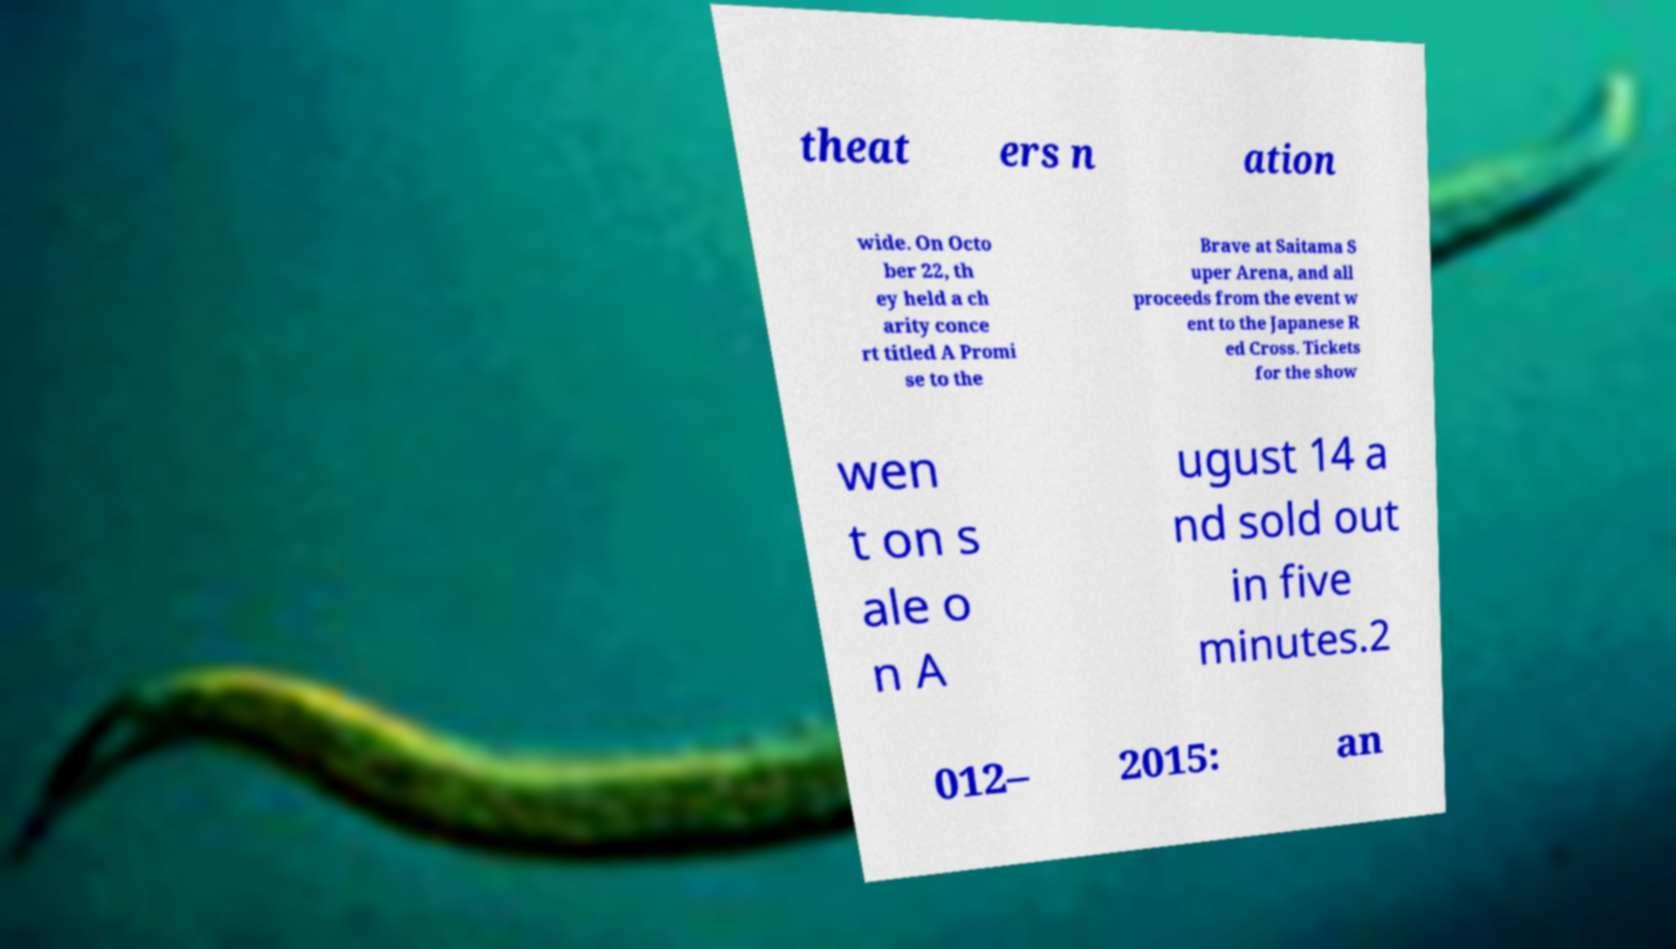For documentation purposes, I need the text within this image transcribed. Could you provide that? theat ers n ation wide. On Octo ber 22, th ey held a ch arity conce rt titled A Promi se to the Brave at Saitama S uper Arena, and all proceeds from the event w ent to the Japanese R ed Cross. Tickets for the show wen t on s ale o n A ugust 14 a nd sold out in five minutes.2 012– 2015: an 